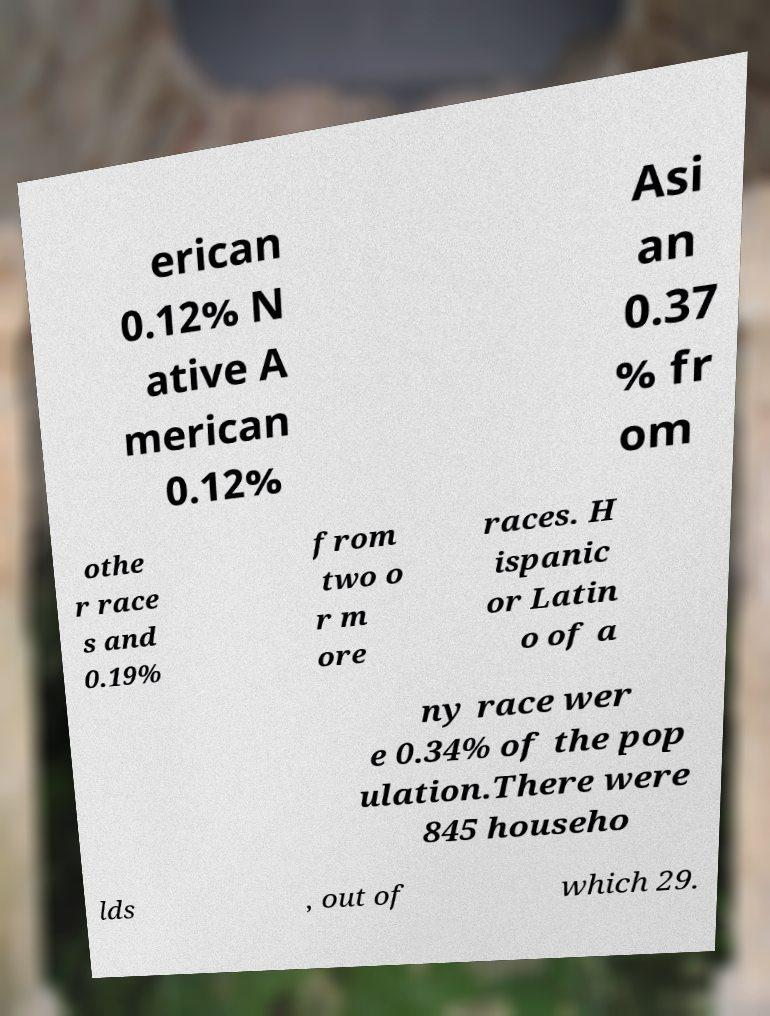Can you read and provide the text displayed in the image?This photo seems to have some interesting text. Can you extract and type it out for me? erican 0.12% N ative A merican 0.12% Asi an 0.37 % fr om othe r race s and 0.19% from two o r m ore races. H ispanic or Latin o of a ny race wer e 0.34% of the pop ulation.There were 845 househo lds , out of which 29. 